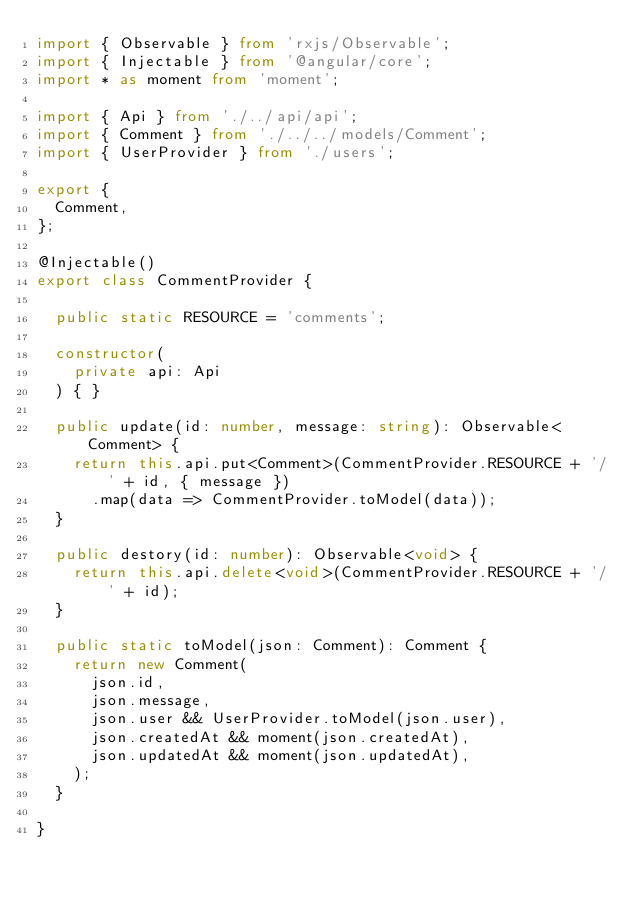Convert code to text. <code><loc_0><loc_0><loc_500><loc_500><_TypeScript_>import { Observable } from 'rxjs/Observable';
import { Injectable } from '@angular/core';
import * as moment from 'moment';

import { Api } from './../api/api';
import { Comment } from './../../models/Comment';
import { UserProvider } from './users';

export {
  Comment,
};

@Injectable()
export class CommentProvider {

  public static RESOURCE = 'comments';

  constructor(
    private api: Api
  ) { }

  public update(id: number, message: string): Observable<Comment> {
    return this.api.put<Comment>(CommentProvider.RESOURCE + '/' + id, { message })
      .map(data => CommentProvider.toModel(data));
  }

  public destory(id: number): Observable<void> {
    return this.api.delete<void>(CommentProvider.RESOURCE + '/' + id);
  }

  public static toModel(json: Comment): Comment {
    return new Comment(
      json.id,
      json.message,
      json.user && UserProvider.toModel(json.user),
      json.createdAt && moment(json.createdAt),
      json.updatedAt && moment(json.updatedAt),
    );
  }

}
</code> 